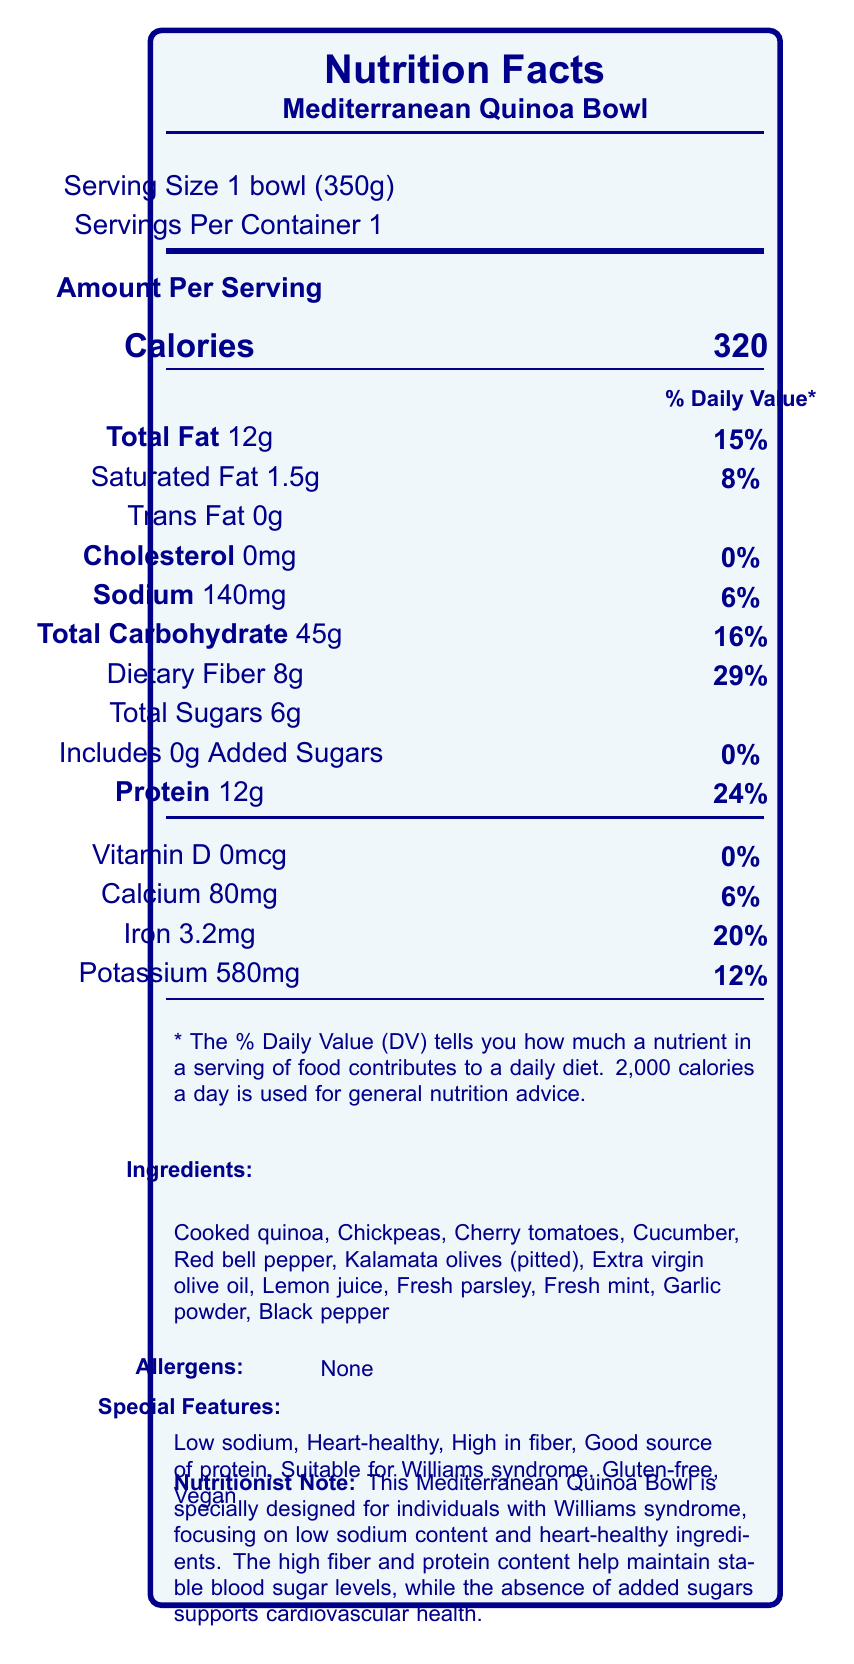what is the serving size for the Mediterranean Quinoa Bowl? The serving size is clearly listed as "1 bowl (350g)" in the document.
Answer: 1 bowl (350g) how much sodium does one bowl contain? The document states that the sodium content per serving is 140mg.
Answer: 140mg what are the main ingredients in the Mediterranean Quinoa Bowl? The ingredients list under the "Ingredients" section includes all of these items.
Answer: Cooked quinoa, Chickpeas, Cherry tomatoes, Cucumber, Red bell pepper, Kalamata olives (pitted), Extra virgin olive oil, Lemon juice, Fresh parsley, Fresh mint, Garlic powder, Black pepper what percentage of the daily value of fiber does the Mediterranean Quinoa Bowl provide? It is mentioned that the dietary fiber content is 8g, which equals 29% of the daily value.
Answer: 29% how much protein is in the Mediterranean Quinoa Bowl? The document notes that there is 12g of protein per serving.
Answer: 12g which of the following nutrients has the highest percentage of daily value: Vitamin D, Calcium, Iron, or Potassium? A. Vitamin D B. Calcium C. Iron D. Potassium The daily values provided are: Vitamin D (0%), Calcium (6%), Iron (20%), and Potassium (12%). Iron has the highest percentage of daily value.
Answer: C. Iron what distinguishes the Mediterranean Quinoa Bowl as being specially suitable for individuals with Williams syndrome? A. High sodium content B. Heart-healthy ingredients C. Gluten-free D. Contains added sugars The document mentions "heart-healthy ingredients" as part of the special features suitable for individuals with Williams syndrome.
Answer: B. Heart-healthy ingredients does the Mediterranean Quinoa Bowl contain any allergens? The "Allergens" section clearly states "None".
Answer: No summarize the key features of the Mediterranean Quinoa Bowl. The summary outlines the main aspects of the product, including its nutritional profile, ingredients, suitability for individuals with Williams syndrome, and storage instructions.
Answer: The Mediterranean Quinoa Bowl is a heart-healthy, low-sodium, and high-fiber entree suitable for individuals with Williams syndrome. It is a good source of protein, gluten-free, and vegan. It contains 12g of protein, 320 calories, and essential nutrients like iron and potassium. The ingredients include cooked quinoa, chickpeas, and various vegetables, without any allergens. It should be consumed within 2 days of opening and kept refrigerated. what is the calorie content of the Mediterranean Quinoa Bowl? The document specifies that the entree contains 320 calories per serving.
Answer: 320 calories how is the Mediterranean Quinoa Bowl prepared for serving? The preparation instructions provide these steps for serving.
Answer: Gently toss all ingredients before serving. Can be served cold or at room temperature. how long can the Mediterranean Quinoa Bowl be stored once opened? The storage instructions specify that the bowl should be consumed within 2 days of opening.
Answer: 2 days what is the scoop? The document does not provide enough information to answer this question.
Answer: Cannot be determined 